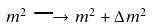Convert formula to latex. <formula><loc_0><loc_0><loc_500><loc_500>m ^ { 2 } \longrightarrow m ^ { 2 } + \Delta m ^ { 2 }</formula> 